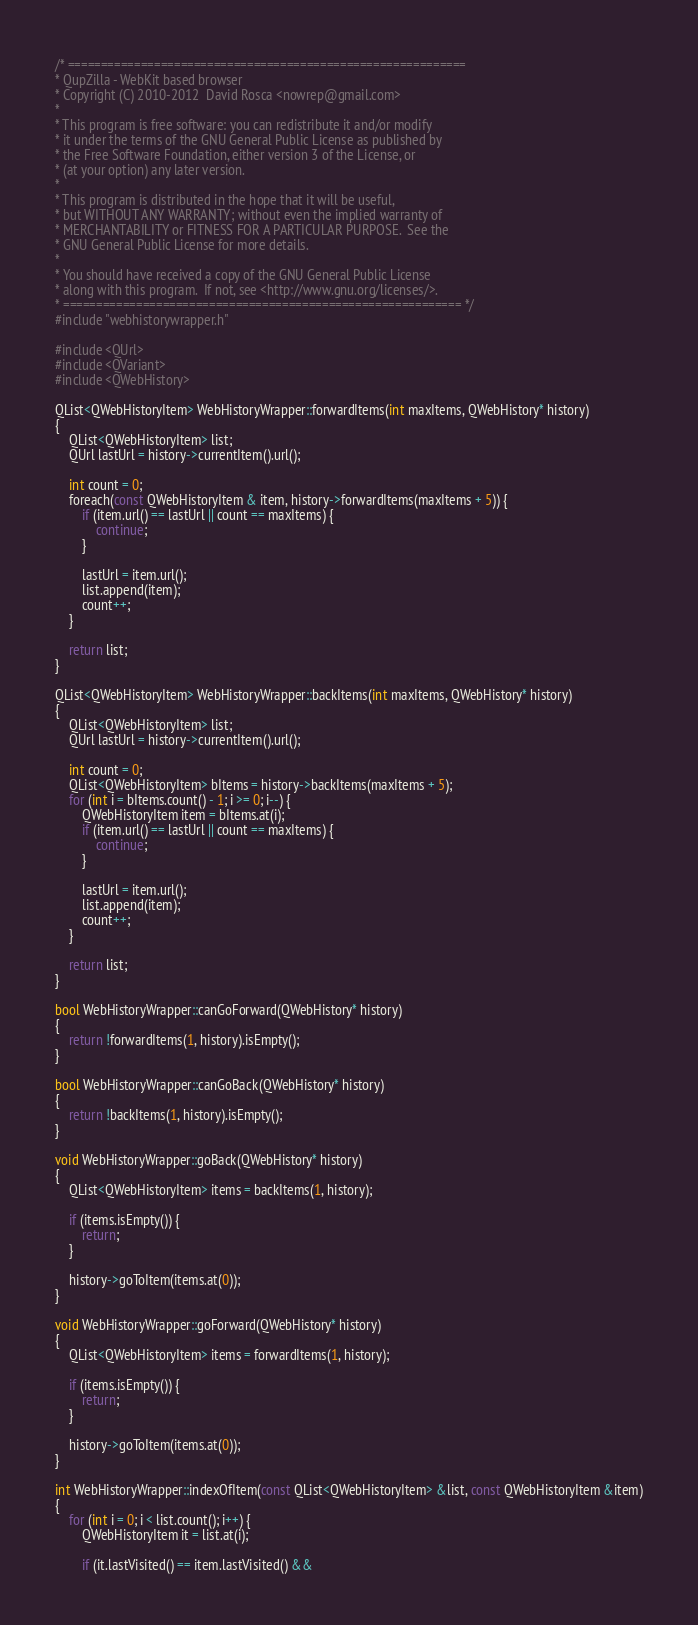<code> <loc_0><loc_0><loc_500><loc_500><_C++_>/* ============================================================
* QupZilla - WebKit based browser
* Copyright (C) 2010-2012  David Rosca <nowrep@gmail.com>
*
* This program is free software: you can redistribute it and/or modify
* it under the terms of the GNU General Public License as published by
* the Free Software Foundation, either version 3 of the License, or
* (at your option) any later version.
*
* This program is distributed in the hope that it will be useful,
* but WITHOUT ANY WARRANTY; without even the implied warranty of
* MERCHANTABILITY or FITNESS FOR A PARTICULAR PURPOSE.  See the
* GNU General Public License for more details.
*
* You should have received a copy of the GNU General Public License
* along with this program.  If not, see <http://www.gnu.org/licenses/>.
* ============================================================ */
#include "webhistorywrapper.h"

#include <QUrl>
#include <QVariant>
#include <QWebHistory>

QList<QWebHistoryItem> WebHistoryWrapper::forwardItems(int maxItems, QWebHistory* history)
{
    QList<QWebHistoryItem> list;
    QUrl lastUrl = history->currentItem().url();

    int count = 0;
    foreach(const QWebHistoryItem & item, history->forwardItems(maxItems + 5)) {
        if (item.url() == lastUrl || count == maxItems) {
            continue;
        }

        lastUrl = item.url();
        list.append(item);
        count++;
    }

    return list;
}

QList<QWebHistoryItem> WebHistoryWrapper::backItems(int maxItems, QWebHistory* history)
{
    QList<QWebHistoryItem> list;
    QUrl lastUrl = history->currentItem().url();

    int count = 0;
    QList<QWebHistoryItem> bItems = history->backItems(maxItems + 5);
    for (int i = bItems.count() - 1; i >= 0; i--) {
        QWebHistoryItem item = bItems.at(i);
        if (item.url() == lastUrl || count == maxItems) {
            continue;
        }

        lastUrl = item.url();
        list.append(item);
        count++;
    }

    return list;
}

bool WebHistoryWrapper::canGoForward(QWebHistory* history)
{
    return !forwardItems(1, history).isEmpty();
}

bool WebHistoryWrapper::canGoBack(QWebHistory* history)
{
    return !backItems(1, history).isEmpty();
}

void WebHistoryWrapper::goBack(QWebHistory* history)
{
    QList<QWebHistoryItem> items = backItems(1, history);

    if (items.isEmpty()) {
        return;
    }

    history->goToItem(items.at(0));
}

void WebHistoryWrapper::goForward(QWebHistory* history)
{
    QList<QWebHistoryItem> items = forwardItems(1, history);

    if (items.isEmpty()) {
        return;
    }

    history->goToItem(items.at(0));
}

int WebHistoryWrapper::indexOfItem(const QList<QWebHistoryItem> &list, const QWebHistoryItem &item)
{
    for (int i = 0; i < list.count(); i++) {
        QWebHistoryItem it = list.at(i);

        if (it.lastVisited() == item.lastVisited() &&</code> 